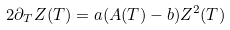<formula> <loc_0><loc_0><loc_500><loc_500>2 \partial _ { T } Z ( T ) = a ( A ( T ) - b ) Z ^ { 2 } ( T )</formula> 